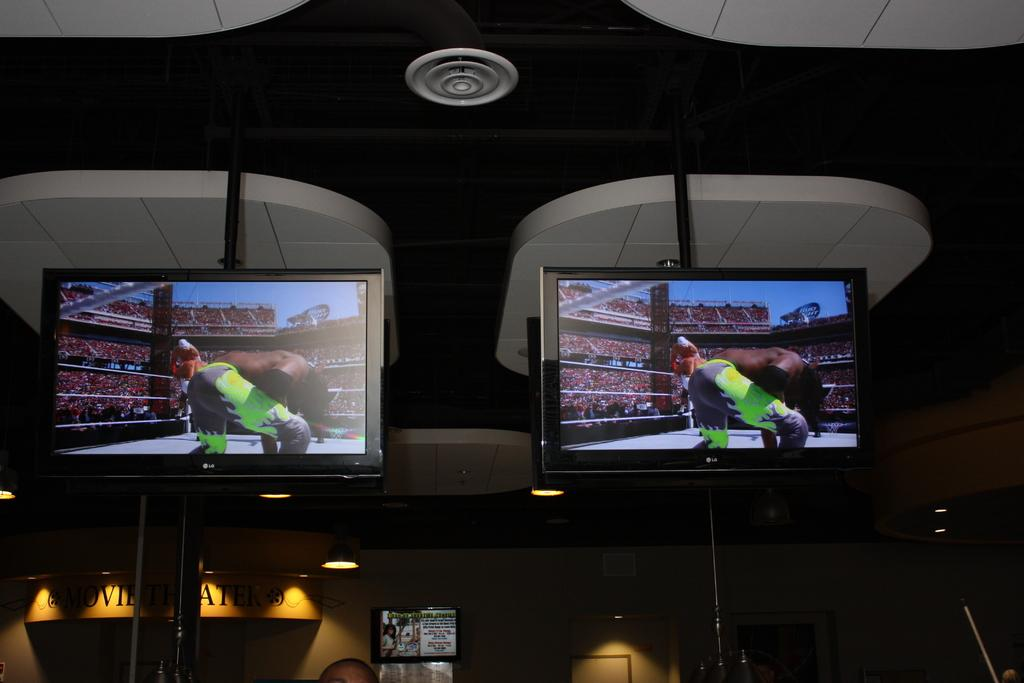<image>
Share a concise interpretation of the image provided. An LG Television on the wall of a restaurant bar. 